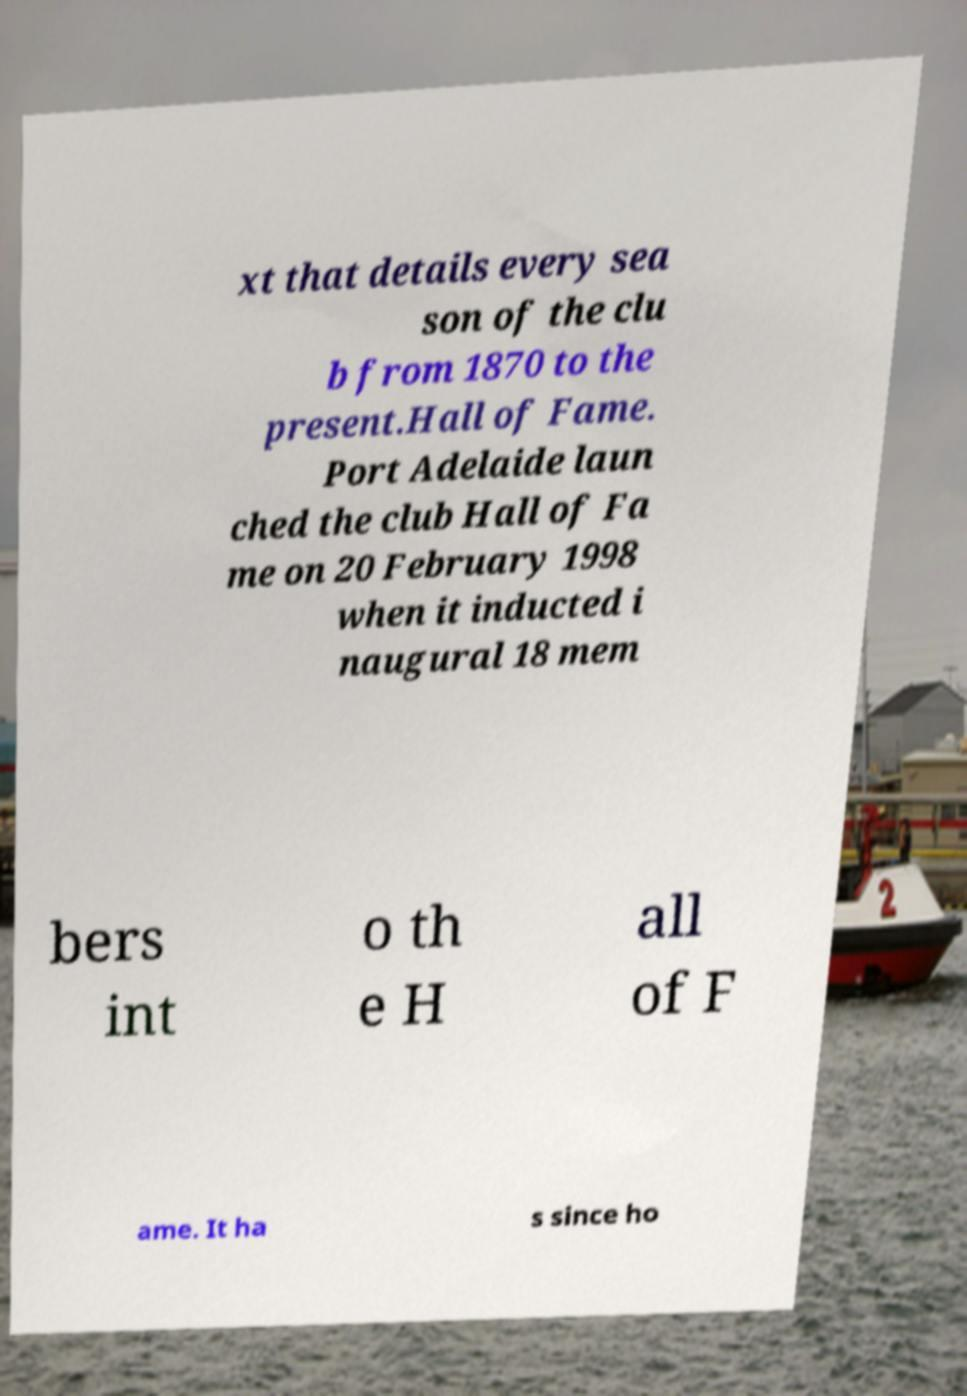Please identify and transcribe the text found in this image. xt that details every sea son of the clu b from 1870 to the present.Hall of Fame. Port Adelaide laun ched the club Hall of Fa me on 20 February 1998 when it inducted i naugural 18 mem bers int o th e H all of F ame. It ha s since ho 